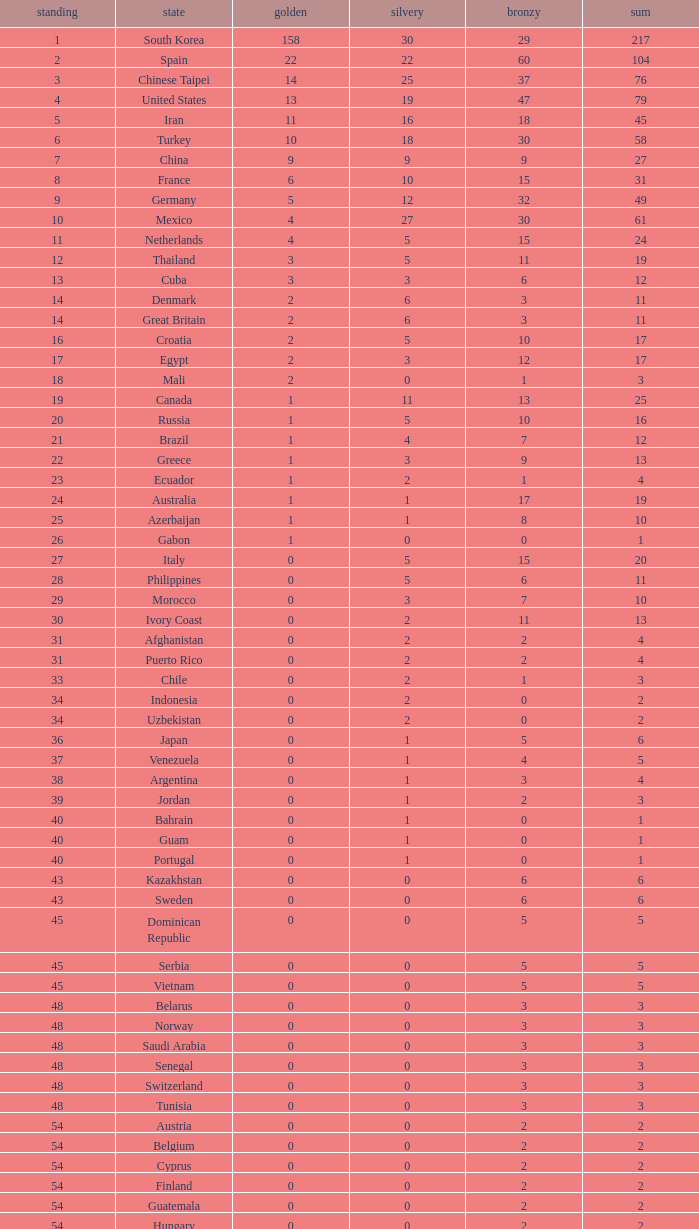What is the Total medals for the Nation ranking 33 with more than 1 Bronze? None. 